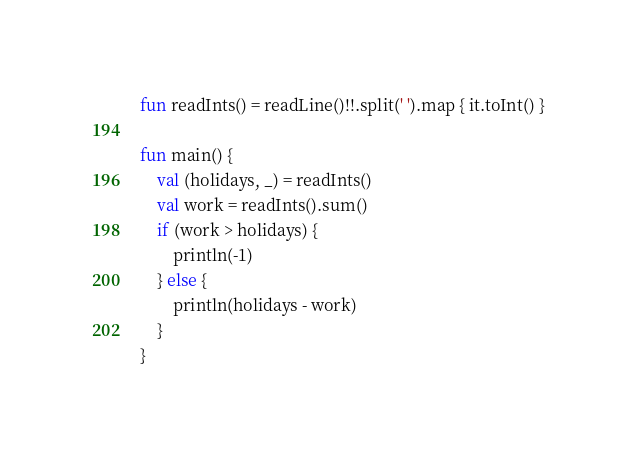Convert code to text. <code><loc_0><loc_0><loc_500><loc_500><_Kotlin_>fun readInts() = readLine()!!.split(' ').map { it.toInt() }

fun main() {
    val (holidays, _) = readInts()
    val work = readInts().sum()
    if (work > holidays) {
        println(-1)
    } else {
        println(holidays - work)
    }
}</code> 